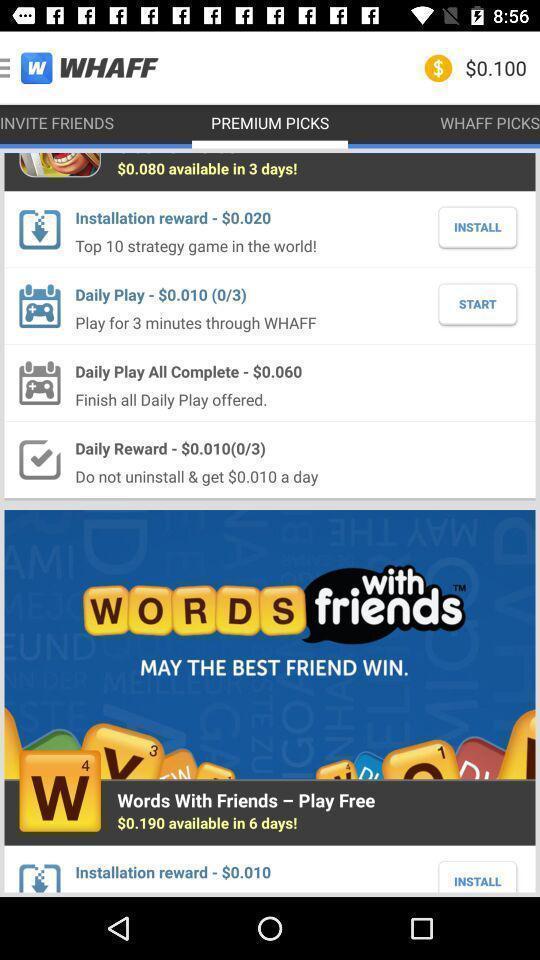Provide a description of this screenshot. Starting page. 